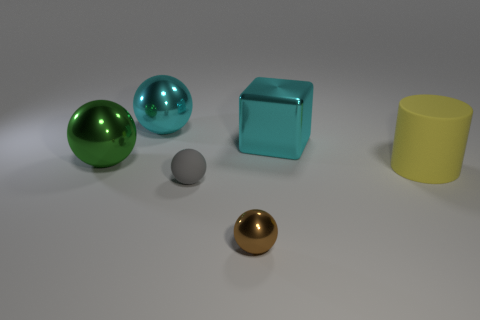Subtract 1 spheres. How many spheres are left? 3 Add 3 small shiny spheres. How many objects exist? 9 Subtract all red balls. Subtract all yellow cubes. How many balls are left? 4 Subtract all cylinders. How many objects are left? 5 Add 3 purple shiny blocks. How many purple shiny blocks exist? 3 Subtract 1 cyan spheres. How many objects are left? 5 Subtract all green metallic things. Subtract all brown shiny blocks. How many objects are left? 5 Add 5 big metal blocks. How many big metal blocks are left? 6 